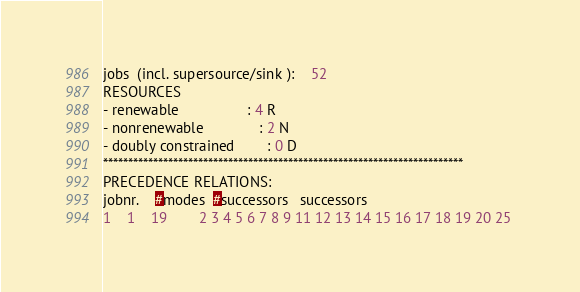<code> <loc_0><loc_0><loc_500><loc_500><_ObjectiveC_>jobs  (incl. supersource/sink ):	52
RESOURCES
- renewable                 : 4 R
- nonrenewable              : 2 N
- doubly constrained        : 0 D
************************************************************************
PRECEDENCE RELATIONS:
jobnr.    #modes  #successors   successors
1	1	19		2 3 4 5 6 7 8 9 11 12 13 14 15 16 17 18 19 20 25 </code> 